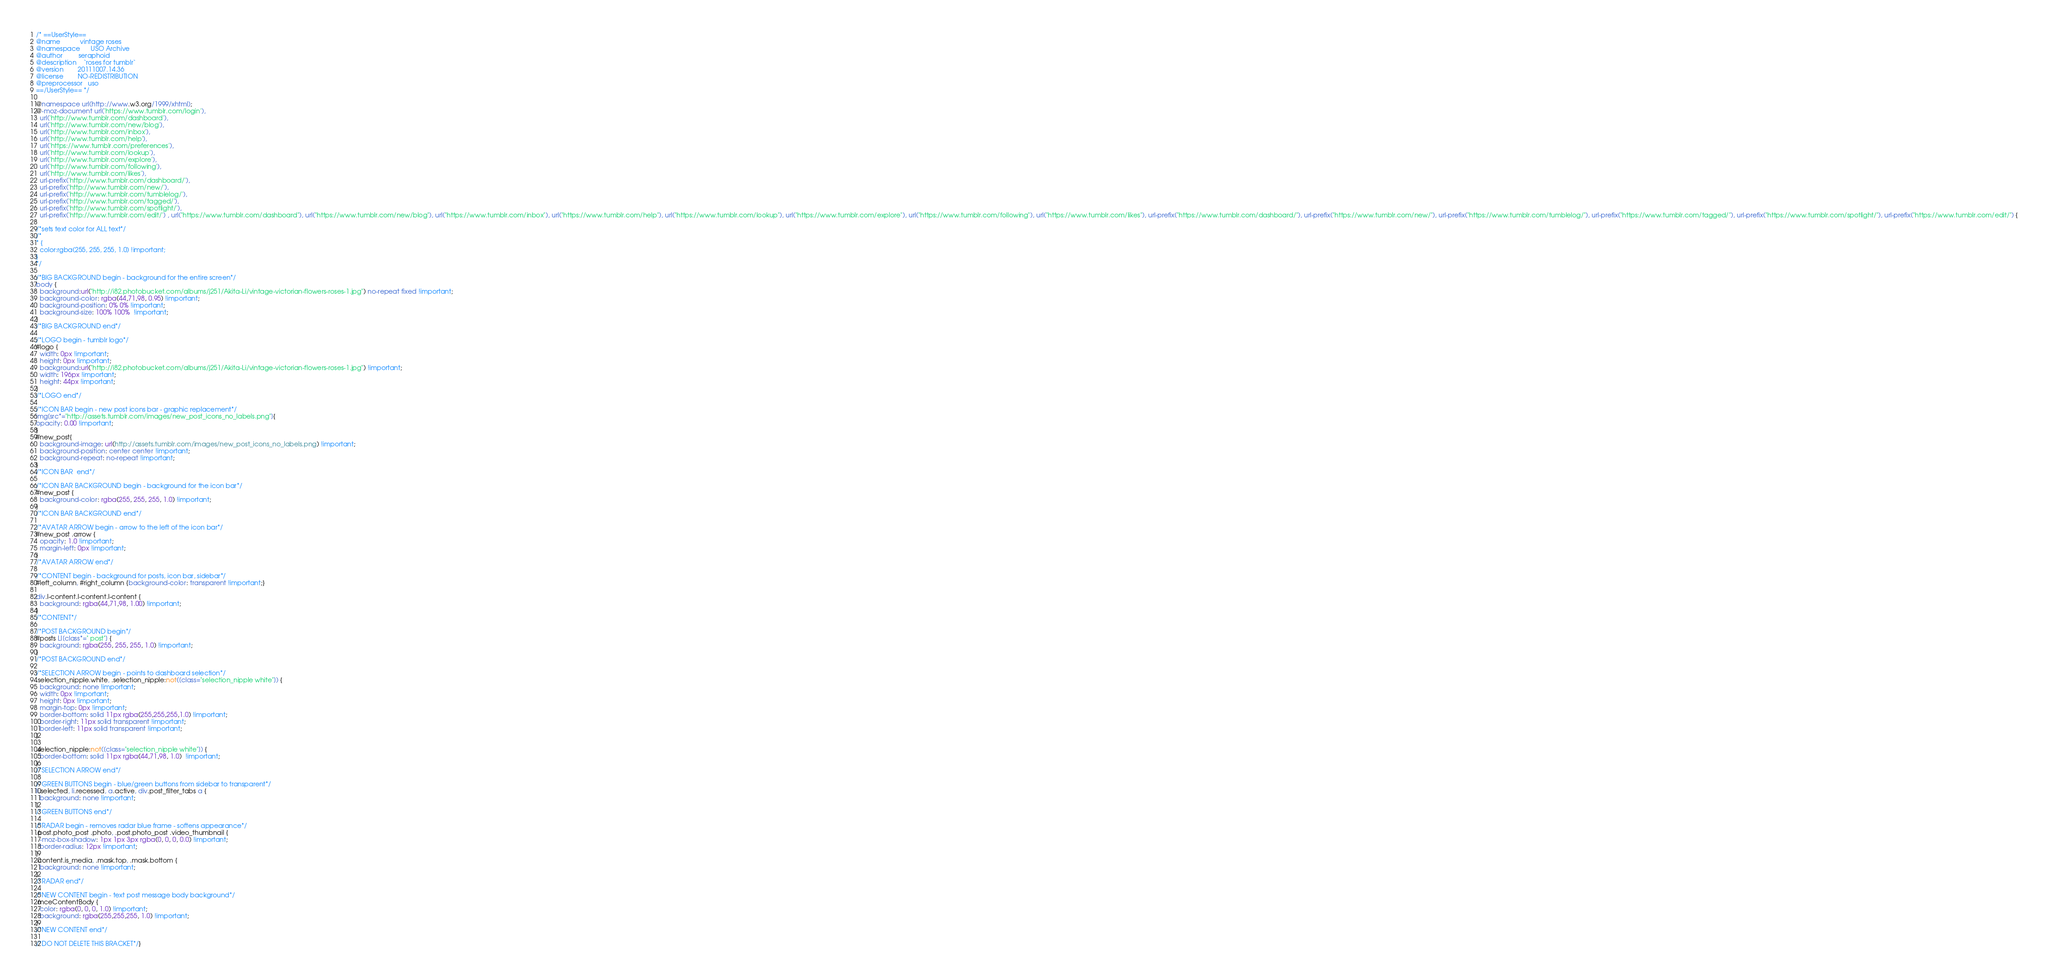<code> <loc_0><loc_0><loc_500><loc_500><_CSS_>/* ==UserStyle==
@name           vintage roses
@namespace      USO Archive
@author         seraphoid
@description    `roses for tumblr`
@version        20111007.14.36
@license        NO-REDISTRIBUTION
@preprocessor   uso
==/UserStyle== */

@namespace url(http://www.w3.org/1999/xhtml);
@-moz-document url('https://www.tumblr.com/login'),
  url('http://www.tumblr.com/dashboard'),
  url('http://www.tumblr.com/new/blog'),
  url('http://www.tumblr.com/inbox'),
  url('http://www.tumblr.com/help'),
  url('https://www.tumblr.com/preferences'),
  url('http://www.tumblr.com/lookup'),
  url('http://www.tumblr.com/explore'),
  url('http://www.tumblr.com/following'),
  url('http://www.tumblr.com/likes'),
  url-prefix('http://www.tumblr.com/dashboard/'),
  url-prefix('http://www.tumblr.com/new/'),
  url-prefix('http://www.tumblr.com/tumblelog/'),
  url-prefix('http://www.tumblr.com/tagged/'),
  url-prefix('http://www.tumblr.com/spotlight/'),
  url-prefix('http://www.tumblr.com/edit/') , url("https://www.tumblr.com/dashboard"), url("https://www.tumblr.com/new/blog"), url("https://www.tumblr.com/inbox"), url("https://www.tumblr.com/help"), url("https://www.tumblr.com/lookup"), url("https://www.tumblr.com/explore"), url("https://www.tumblr.com/following"), url("https://www.tumblr.com/likes"), url-prefix("https://www.tumblr.com/dashboard/"), url-prefix("https://www.tumblr.com/new/"), url-prefix("https://www.tumblr.com/tumblelog/"), url-prefix("https://www.tumblr.com/tagged/"), url-prefix("https://www.tumblr.com/spotlight/"), url-prefix("https://www.tumblr.com/edit/") {

/*sets text color for ALL text*/
/*
* {
  color:rgba(255, 255, 255, 1.0) !important;
}
*/

/*BIG BACKGROUND begin - background for the entire screen*/
body {
  background:url("http://i82.photobucket.com/albums/j251/Akita-Li/vintage-victorian-flowers-roses-1.jpg") no-repeat fixed !important;
  background-color: rgba(44,71,98, 0.95) !important;
  background-position: 0% 0% !important;
  background-size: 100% 100%  !important;
}
/*BIG BACKGROUND end*/

/*LOGO begin - tumblr logo*/
#logo {
  width: 0px !important;
  height: 0px !important;
  background:url("http://i82.photobucket.com/albums/j251/Akita-Li/vintage-victorian-flowers-roses-1.jpg") !important;
  width: 196px !important;
  height: 44px !important;
}
/*LOGO end*/

/*ICON BAR begin - new post icons bar - graphic replacement*/
img[src*="http://assets.tumblr.com/images/new_post_icons_no_labels.png"]{
opacity: 0.00 !important;  
}
#new_post{
  background-image: url(http://assets.tumblr.com/images/new_post_icons_no_labels.png) !important;
  background-position: center center !important; 
  background-repeat: no-repeat !important;
}
/*ICON BAR  end*/

/*ICON BAR BACKGROUND begin - background for the icon bar*/
#new_post {
  background-color: rgba(255, 255, 255, 1.0) !important;
}
/*ICON BAR BACKGROUND end*/

/*AVATAR ARROW begin - arrow to the left of the icon bar*/
#new_post .arrow {
  opacity: 1.0 !important;
  margin-left: 0px !important; 
}
/*AVATAR ARROW end*/

/*CONTENT begin - background for posts, icon bar, sidebar*/
#left_column, #right_column {background-color: transparent !important;}

div.l-content.l-content.l-content {
  background: rgba(44,71,98, 1.00) !important;
}
/*CONTENT*/ 

/*POST BACKGROUND begin*/
#posts LI[class*=" post"] {
  background: rgba(255, 255, 255, 1.0) !important;
}
/*POST BACKGROUND end*/

/*SELECTION ARROW begin - points to dashboard selection*/
.selection_nipple.white, .selection_nipple:not([class="selection_nipple white"]) {
  background: none !important;
  width: 0px !important;
  height: 0px !important;
  margin-top: 0px !important;
  border-bottom: solid 11px rgba(255,255,255,1.0) !important;
  border-right: 11px solid transparent !important;
  border-left: 11px solid transparent !important;
}

.selection_nipple:not([class="selection_nipple white"]) {
  border-bottom: solid 11px rgba(44,71,98, 1.0)  !important;
}
/*SELECTION ARROW end*/

/*GREEN BUTTONS begin - blue/green buttons from sidebar to transparent*/
li.selected, li.recessed, a.active, div.post_filter_tabs a {
  background: none !important;
}
/*GREEN BUTTONS end*/

/*RADAR begin - removes radar blue frame - softens appearance*/
.post.photo_post .photo, .post.photo_post .video_thumbnail {
  -moz-box-shadow: 1px 1px 3px rgba(0, 0, 0, 0.0) !important;
  border-radius: 12px !important;
}
.content.is_media, .mask.top, .mask.bottom {
  background: none !important;
}
/*RADAR end*/

/*NEW CONTENT begin - text post message body background*/
.mceContentBody {
  color: rgba(0, 0, 0, 1.0) !important;
  background: rgba(255,255,255, 1.0) !important;
}
/*NEW CONTENT end*/

/*DO NOT DELETE THIS BRACKET*/}
</code> 